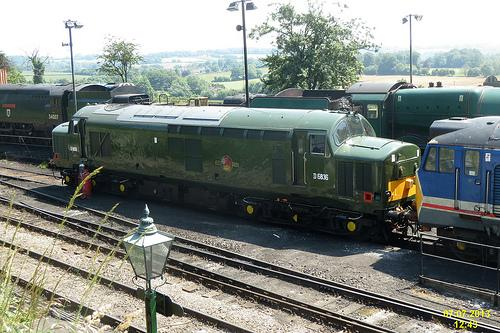What is the primary setting of the image, and what is in front of and behind the main subject? The primary setting is a train yard with train cars and engines. Tall grass is in front, and green trees are behind. Enumerate three different elements that are not part of the trains, visible in the image. A small tree, tall green weeds, and a time stamp in the corner of the photo are visible. Mention the most dominant color of the train and identify a detail that has the same color.  The train is predominantly dark green, and there is a green lamp post as well. Do any of the train cars have stripes or significant markings, and if so, what colors are they? One of the train cars has a yellow stripe and another has a red stripe down its side. List three distinct characteristics of the train engine in the image. The train engine is green, has white numbers on its side, and yellow stripes on its back. Describe the general aesthetic of the image, in terms of the overall sentiment it may convey. The image has a calm and nostalgic sentiment with multiple train cars and tracks surrounded by greenery. How many train cars and engines can be seen in the image, and what colors are they? There are multiple train cars and engines, mostly green, with one blue train car and a red stripe. Are any street lamps visible in the image, and what do they look like? Yes, there's a green street lamp with a glass hurricane cover near the tracks. Enumerate a few features in the environment surrounding the trains. Features include railroad tracks, green trees, tall weeds, and a lamp on a tall pole. 